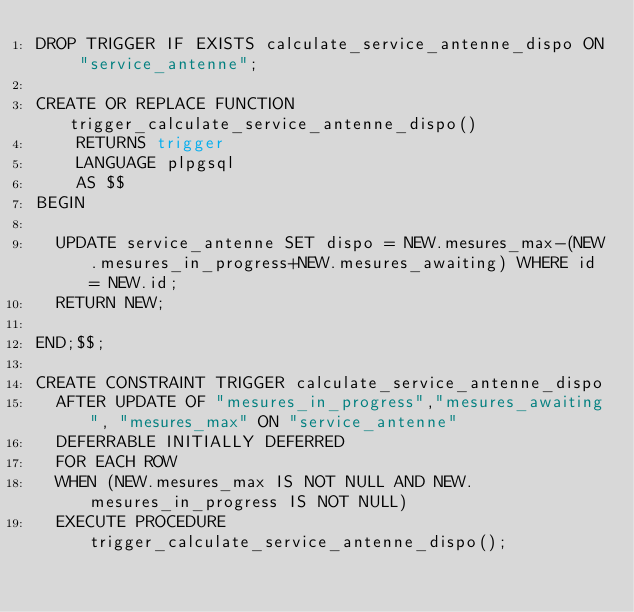Convert code to text. <code><loc_0><loc_0><loc_500><loc_500><_SQL_>DROP TRIGGER IF EXISTS calculate_service_antenne_dispo ON "service_antenne";

CREATE OR REPLACE FUNCTION trigger_calculate_service_antenne_dispo()
    RETURNS trigger
    LANGUAGE plpgsql
    AS $$
BEGIN

  UPDATE service_antenne SET dispo = NEW.mesures_max-(NEW.mesures_in_progress+NEW.mesures_awaiting) WHERE id = NEW.id;
  RETURN NEW;

END;$$;

CREATE CONSTRAINT TRIGGER calculate_service_antenne_dispo
  AFTER UPDATE OF "mesures_in_progress","mesures_awaiting", "mesures_max" ON "service_antenne"
  DEFERRABLE INITIALLY DEFERRED
  FOR EACH ROW
  WHEN (NEW.mesures_max IS NOT NULL AND NEW.mesures_in_progress IS NOT NULL)
  EXECUTE PROCEDURE trigger_calculate_service_antenne_dispo();
</code> 